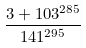Convert formula to latex. <formula><loc_0><loc_0><loc_500><loc_500>\frac { 3 + 1 0 3 ^ { 2 8 5 } } { 1 4 1 ^ { 2 9 5 } }</formula> 